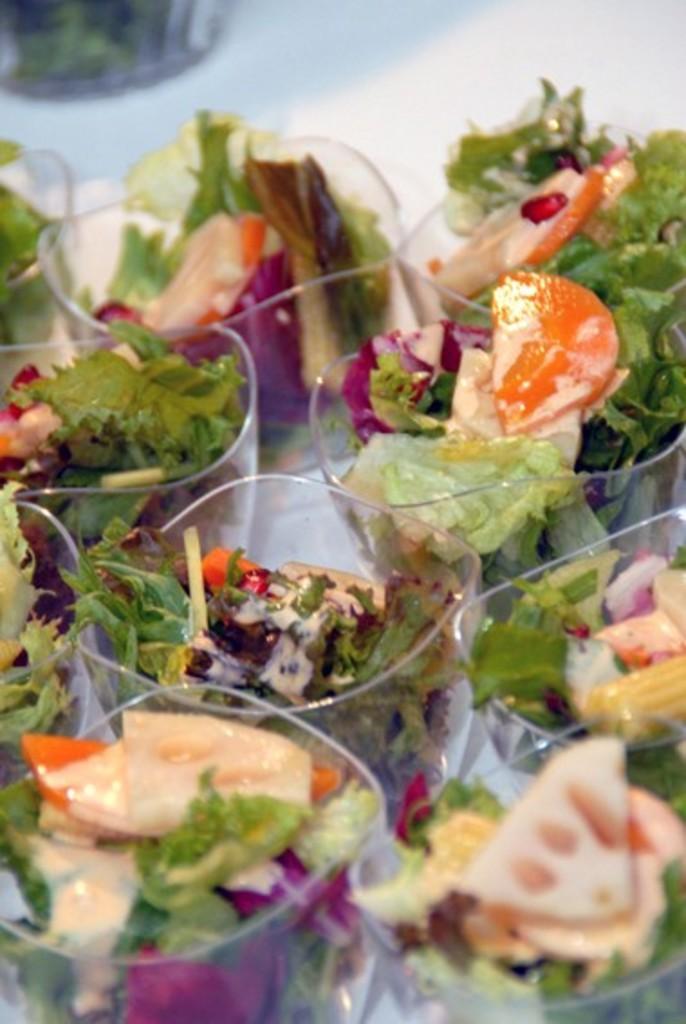Can you describe this image briefly? In the picture there is some salad served in the cups and kept on a white surface. 